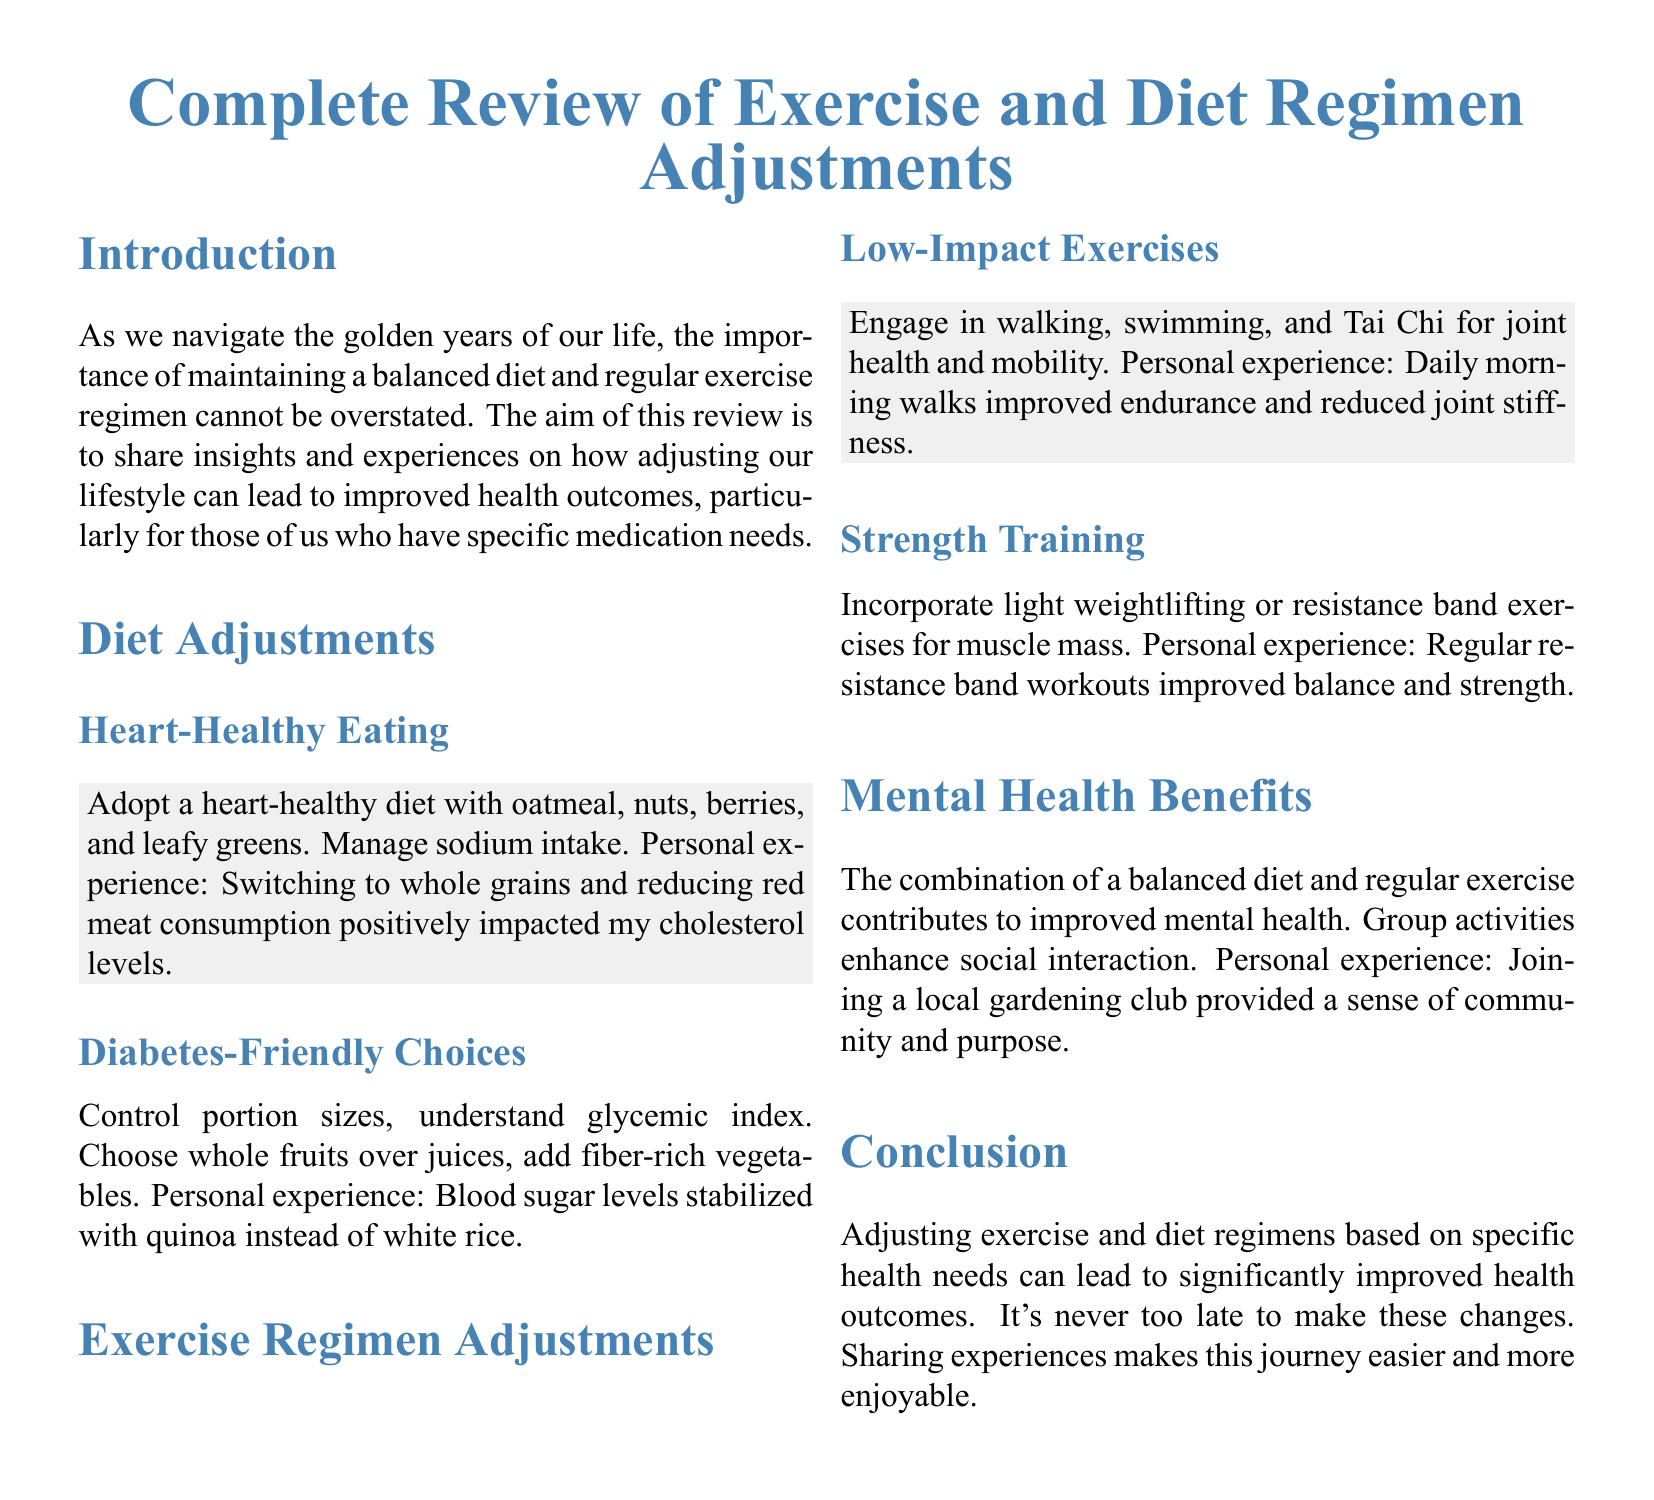What is the main focus of the review? The review aims to share insights and experiences on adjusting lifestyle for improved health outcomes, especially for those with specific medication needs.
Answer: Improved health outcomes What types of foods are recommended for heart-healthy eating? The document lists oatmeal, nuts, berries, and leafy greens as examples of heart-healthy foods.
Answer: Oatmeal, nuts, berries, leafy greens What exercise is suggested for joint health? The document mentions low-impact exercises such as walking, swimming, and Tai Chi for maintaining joint health and mobility.
Answer: Walking, swimming, Tai Chi What personal experience is shared regarding blood sugar levels? The review states that blood sugar levels stabilized with the substitution of quinoa for white rice.
Answer: Quinoa instead of white rice What social benefit is mentioned associated with exercise and diet? The document highlights that group activities enhance social interaction as a mental health benefit.
Answer: Social interaction What is stated about strength training? The document advises incorporating light weightlifting or resistance band exercises to improve muscle mass.
Answer: Light weightlifting or resistance band exercises What impact did daily morning walks have according to personal experience? The review shares that daily morning walks improved endurance and reduced joint stiffness.
Answer: Improved endurance and reduced joint stiffness What is the conclusion about making lifestyle changes? The conclusion emphasizes that adjusting exercise and diet regimens can lead to significantly improved health outcomes.
Answer: Significantly improved health outcomes What type of document is this? The document is an appraisal form focused on lifestyle adjustments for health improvement.
Answer: Appraisal form 